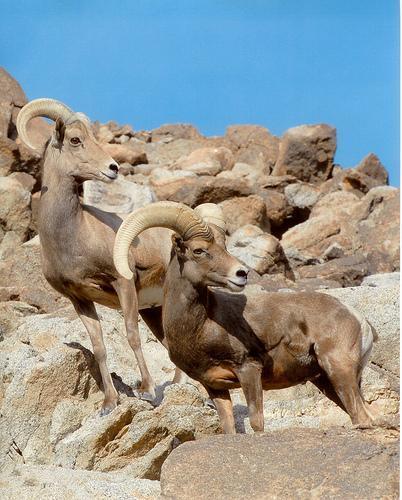How many rams are in this photo?
Give a very brief answer. 2. How many horns are on each ram's head?
Give a very brief answer. 2. 